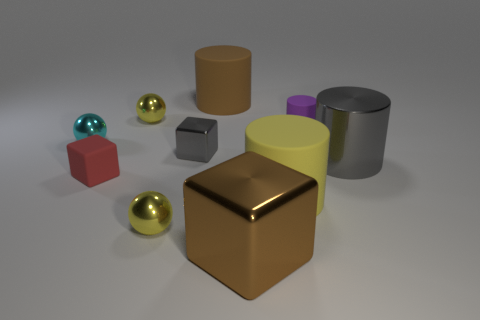There is a rubber thing that is in front of the cyan metallic thing and left of the brown cube; what is its color?
Provide a succinct answer. Red. What size is the cube that is behind the metal thing that is on the right side of the large metallic cube?
Ensure brevity in your answer.  Small. Are there any tiny blocks that have the same color as the tiny rubber cylinder?
Offer a very short reply. No. Is the number of yellow cylinders behind the red rubber thing the same as the number of tiny blocks?
Your response must be concise. No. What number of tiny gray things are there?
Give a very brief answer. 1. What is the shape of the rubber thing that is both to the right of the red thing and on the left side of the large brown metal thing?
Give a very brief answer. Cylinder. There is a tiny matte thing that is in front of the cyan object; does it have the same color as the metallic cube that is in front of the large yellow thing?
Provide a succinct answer. No. There is a metallic cube that is the same color as the shiny cylinder; what is its size?
Your response must be concise. Small. Are there any gray cylinders that have the same material as the large yellow thing?
Provide a succinct answer. No. Are there an equal number of large cylinders that are left of the small purple rubber object and purple things in front of the big gray metallic cylinder?
Offer a very short reply. No. 